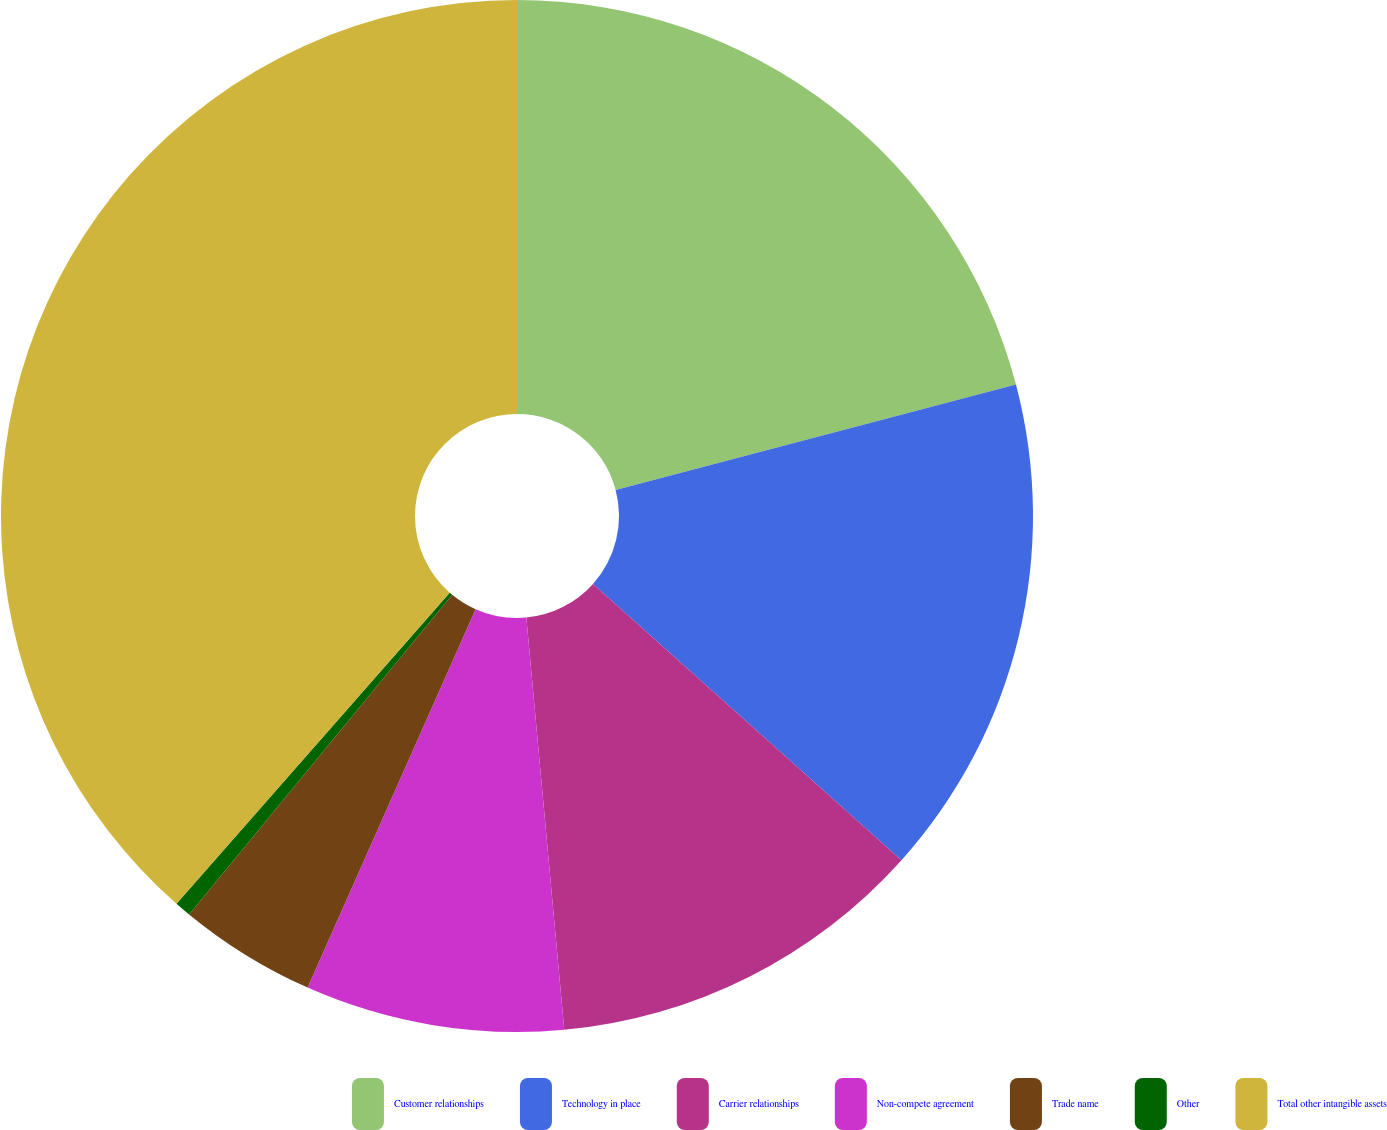Convert chart to OTSL. <chart><loc_0><loc_0><loc_500><loc_500><pie_chart><fcel>Customer relationships<fcel>Technology in place<fcel>Carrier relationships<fcel>Non-compete agreement<fcel>Trade name<fcel>Other<fcel>Total other intangible assets<nl><fcel>20.9%<fcel>15.72%<fcel>11.92%<fcel>8.11%<fcel>4.31%<fcel>0.51%<fcel>38.53%<nl></chart> 